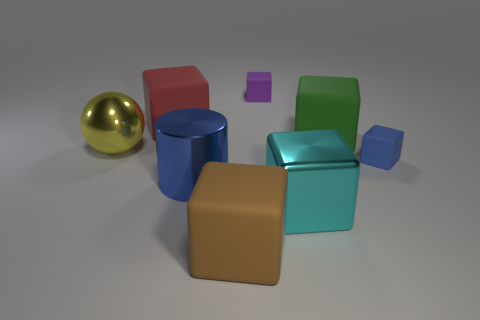Is there a brown thing of the same shape as the cyan thing?
Your answer should be very brief. Yes. What is the size of the ball that is to the left of the red matte block?
Ensure brevity in your answer.  Large. What is the material of the blue cylinder that is the same size as the cyan object?
Your response must be concise. Metal. Are there more tiny purple metallic cubes than green matte things?
Your answer should be very brief. No. There is a block to the left of the matte object that is in front of the cyan metal block; how big is it?
Offer a very short reply. Large. What is the shape of the yellow metallic thing that is the same size as the cyan block?
Your answer should be very brief. Sphere. What is the shape of the small thing to the right of the tiny thing behind the big rubber cube that is to the left of the large brown rubber thing?
Offer a very short reply. Cube. There is a tiny thing behind the large yellow shiny thing; does it have the same color as the tiny matte block that is in front of the large red rubber object?
Your response must be concise. No. What number of tiny blocks are there?
Give a very brief answer. 2. Are there any large metal blocks on the right side of the green rubber block?
Provide a short and direct response. No. 